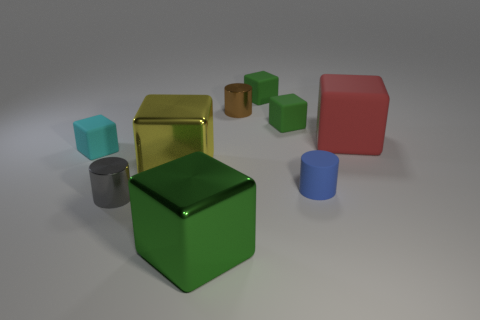As an artist, what emotions or themes could you interpret from the arrangement and colors of these objects? The image presents a serene and somewhat minimalist scene with its muted colors and simple geometric forms. The arrangement could evoke a sense of order and tranquility. The varying sizes might symbolize growth or progression, and the different colors and materials might represent diversity or individuality within a collective group. 